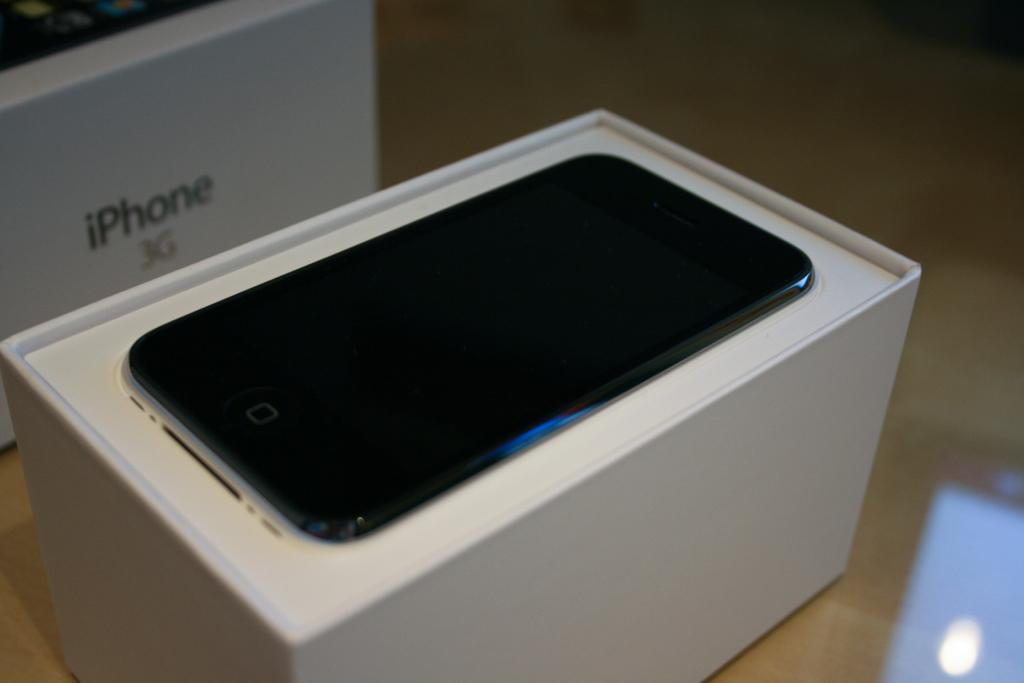Provide a one-sentence caption for the provided image. An iphone 3G is displayed in a white box. 